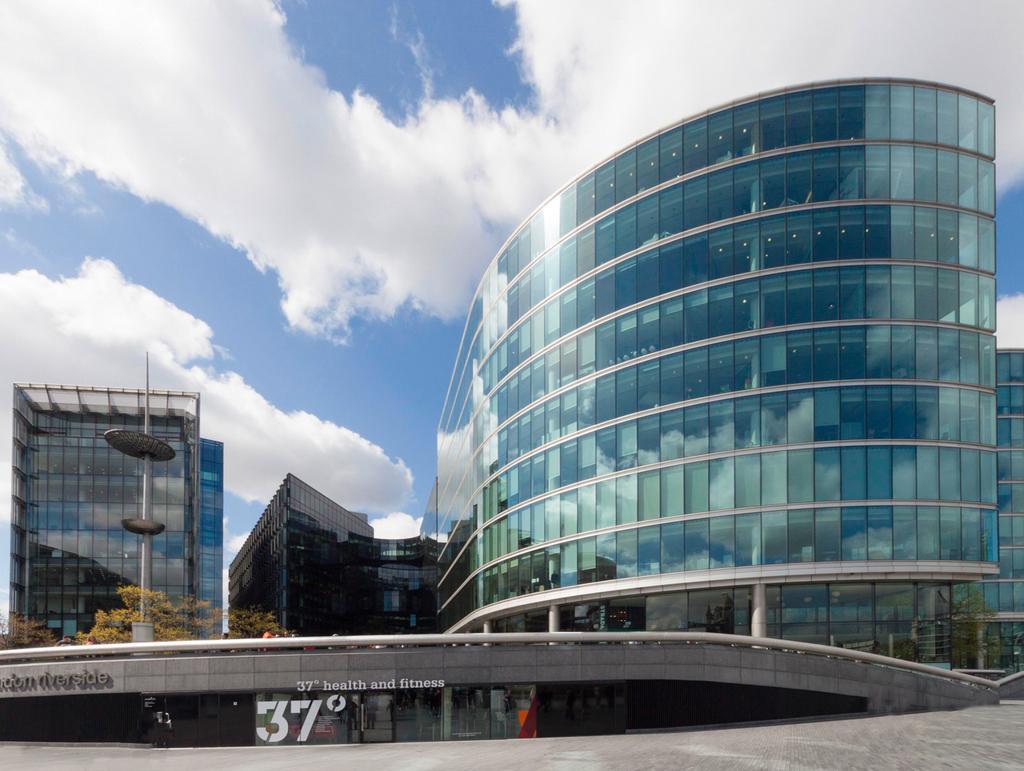Can you describe this image briefly? In this image, we can see some buildings and a pole. We can also see the bridge and the ground. We can see some trees and the sky with clouds. We can see some text at the bottom. We can see the glass with the reflection. 